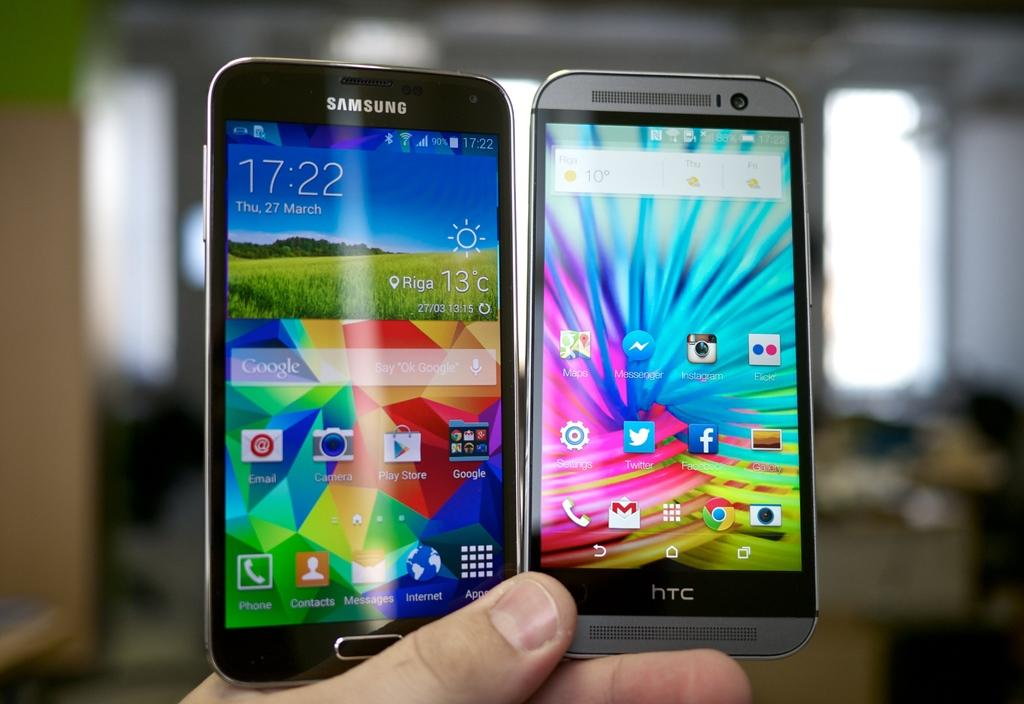<image>
Present a compact description of the photo's key features. A samsung galaxy phone held next to a htc phone in someones hand. 